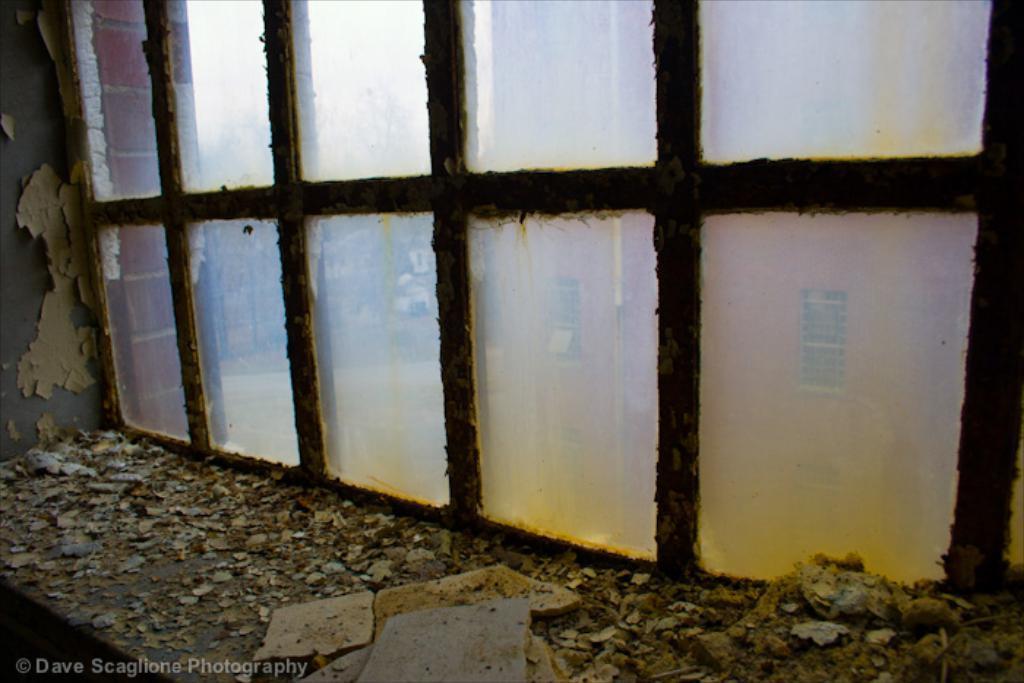Please provide a concise description of this image. In this picture, it looks like inner view of a old building and I can see glass window, from the glass I can see building and trees and I can see text at the bottom left corner of the picture and I can see dust. 